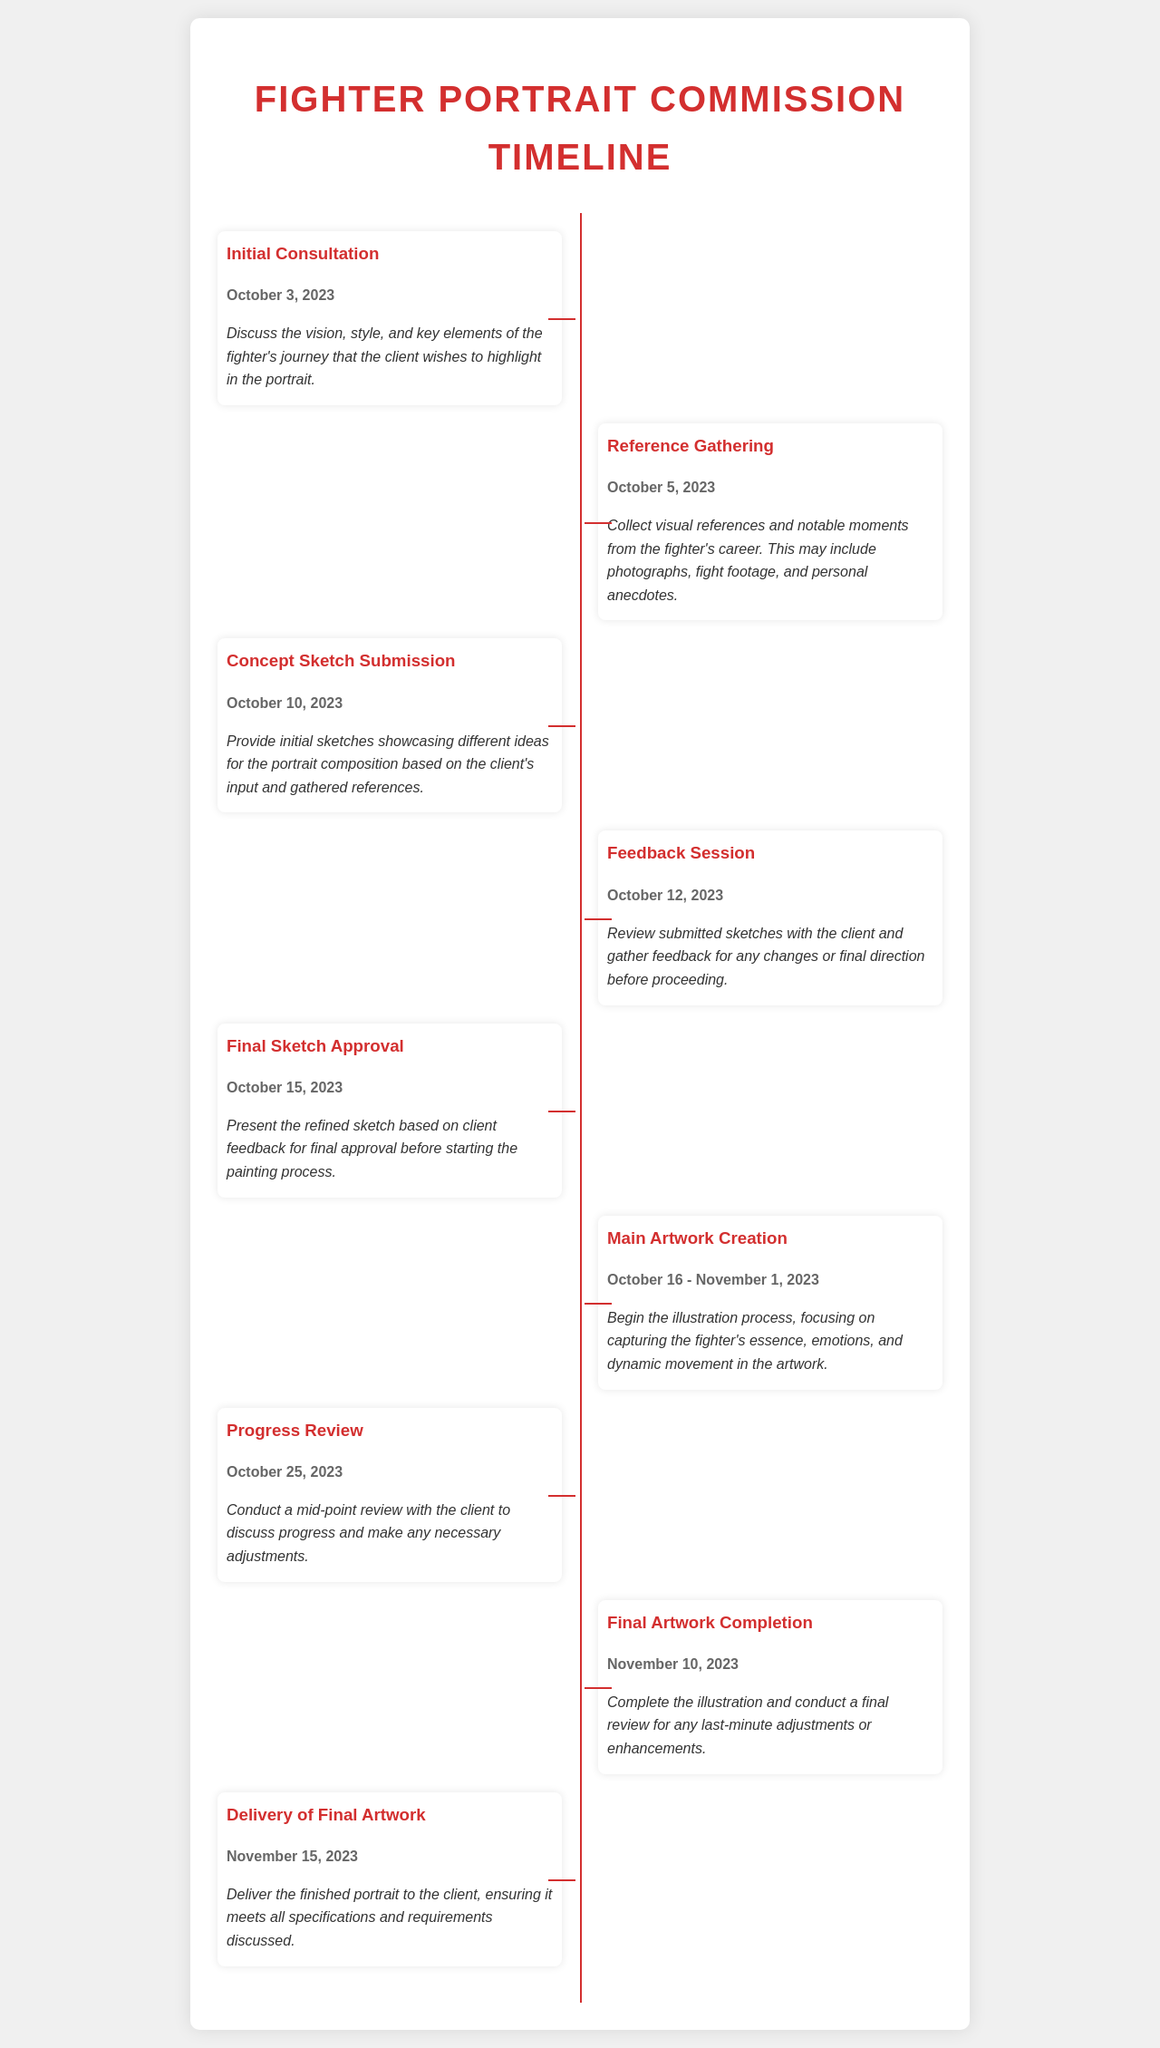What date is the Initial Consultation scheduled for? The Initial Consultation is the first milestone in the timeline, which lists the specific date assigned to it.
Answer: October 3, 2023 When is the Final Artwork Completion deadline? The document outlines the deadline for each milestone, including the completion date of the final artwork.
Answer: November 10, 2023 How long is the Main Artwork Creation phase? The duration of this phase is indicated as a date range, showing the start and end dates.
Answer: October 16 - November 1, 2023 What is the purpose of the Feedback Session? This question requires associating the event with its objective mentioned in the document.
Answer: Gather feedback What occurs on October 25, 2023? The timeline highlights specific milestones dated on this day.
Answer: Progress Review How many days are there between the Final Sketch Approval and the Final Artwork Completion? This requires calculating the number of days from one milestone to another based on the provided dates.
Answer: 26 days What is the main focus during the Main Artwork Creation? The document specifies the key aspects that should be captured during this phase of the portrait creation.
Answer: Fighter's essence What is discussed during the Initial Consultation? The description for this milestone details the topics addressed during the consultation.
Answer: Vision, style, and key elements When will the client receive the final artwork? The delivery date for the final artwork is explicitly given in the timeline, providing specific information.
Answer: November 15, 2023 